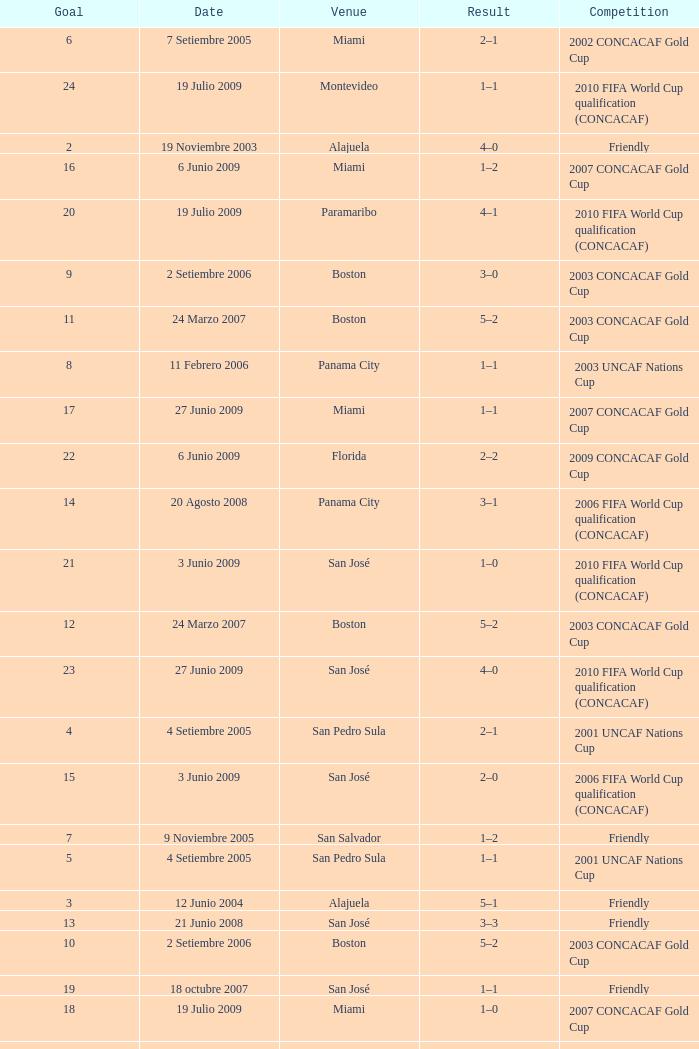I'm looking to parse the entire table for insights. Could you assist me with that? {'header': ['Goal', 'Date', 'Venue', 'Result', 'Competition'], 'rows': [['6', '7 Setiembre 2005', 'Miami', '2–1', '2002 CONCACAF Gold Cup'], ['24', '19 Julio 2009', 'Montevideo', '1–1', '2010 FIFA World Cup qualification (CONCACAF)'], ['2', '19 Noviembre 2003', 'Alajuela', '4–0', 'Friendly'], ['16', '6 Junio 2009', 'Miami', '1–2', '2007 CONCACAF Gold Cup'], ['20', '19 Julio 2009', 'Paramaribo', '4–1', '2010 FIFA World Cup qualification (CONCACAF)'], ['9', '2 Setiembre 2006', 'Boston', '3–0', '2003 CONCACAF Gold Cup'], ['11', '24 Marzo 2007', 'Boston', '5–2', '2003 CONCACAF Gold Cup'], ['8', '11 Febrero 2006', 'Panama City', '1–1', '2003 UNCAF Nations Cup'], ['17', '27 Junio 2009', 'Miami', '1–1', '2007 CONCACAF Gold Cup'], ['22', '6 Junio 2009', 'Florida', '2–2', '2009 CONCACAF Gold Cup'], ['14', '20 Agosto 2008', 'Panama City', '3–1', '2006 FIFA World Cup qualification (CONCACAF)'], ['21', '3 Junio 2009', 'San José', '1–0', '2010 FIFA World Cup qualification (CONCACAF)'], ['12', '24 Marzo 2007', 'Boston', '5–2', '2003 CONCACAF Gold Cup'], ['23', '27 Junio 2009', 'San José', '4–0', '2010 FIFA World Cup qualification (CONCACAF)'], ['4', '4 Setiembre 2005', 'San Pedro Sula', '2–1', '2001 UNCAF Nations Cup'], ['15', '3 Junio 2009', 'San José', '2–0', '2006 FIFA World Cup qualification (CONCACAF)'], ['7', '9 Noviembre 2005', 'San Salvador', '1–2', 'Friendly'], ['5', '4 Setiembre 2005', 'San Pedro Sula', '1–1', '2001 UNCAF Nations Cup'], ['3', '12 Junio 2004', 'Alajuela', '5–1', 'Friendly'], ['13', '21 Junio 2008', 'San José', '3–3', 'Friendly'], ['10', '2 Setiembre 2006', 'Boston', '5–2', '2003 CONCACAF Gold Cup'], ['19', '18 octubre 2007', 'San José', '1–1', 'Friendly'], ['18', '19 Julio 2009', 'Miami', '1–0', '2007 CONCACAF Gold Cup'], ['1', '7 Setiembre 2003', 'San José', '9–0', 'Friendly']]} At the venue of panama city, on 11 Febrero 2006, how many goals were scored? 1.0. 